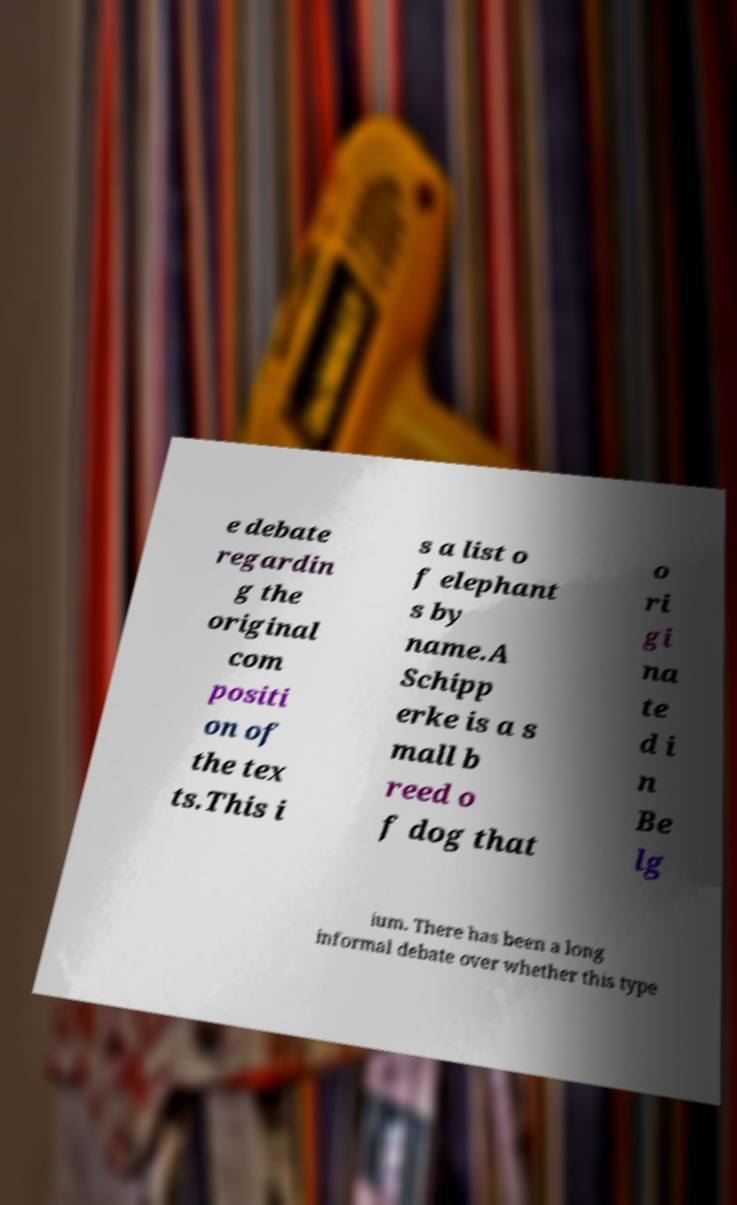Please identify and transcribe the text found in this image. e debate regardin g the original com positi on of the tex ts.This i s a list o f elephant s by name.A Schipp erke is a s mall b reed o f dog that o ri gi na te d i n Be lg ium. There has been a long informal debate over whether this type 